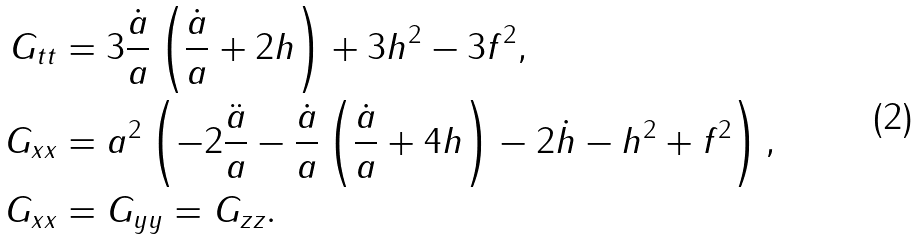Convert formula to latex. <formula><loc_0><loc_0><loc_500><loc_500>G _ { t t } & = 3 \frac { \dot { a } } { a } \left ( \frac { \dot { a } } { a } + 2 h \right ) + 3 h ^ { 2 } - 3 f ^ { 2 } , \\ G _ { x x } & = a ^ { 2 } \left ( - 2 \frac { \ddot { a } } { a } - \frac { \dot { a } } { a } \left ( \frac { \dot { a } } { a } + 4 h \right ) - 2 \dot { h } - h ^ { 2 } + f ^ { 2 } \right ) , \\ G _ { x x } & = G _ { y y } = G _ { z z } .</formula> 